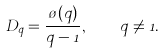Convert formula to latex. <formula><loc_0><loc_0><loc_500><loc_500>D _ { q } = \frac { \tau ( q ) } { q - 1 } , \quad q \neq 1 .</formula> 